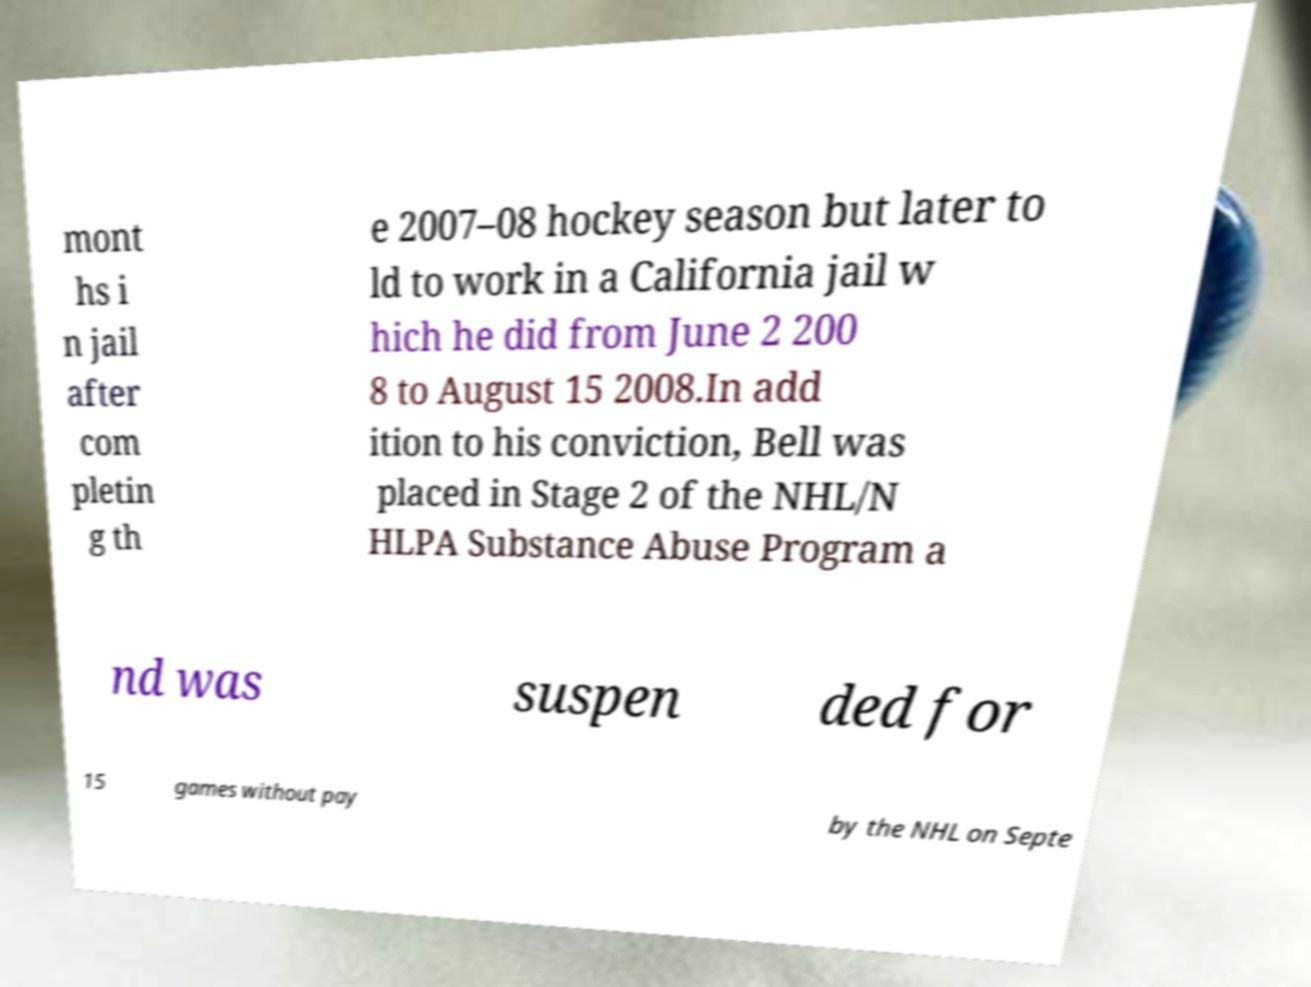Please identify and transcribe the text found in this image. mont hs i n jail after com pletin g th e 2007–08 hockey season but later to ld to work in a California jail w hich he did from June 2 200 8 to August 15 2008.In add ition to his conviction, Bell was placed in Stage 2 of the NHL/N HLPA Substance Abuse Program a nd was suspen ded for 15 games without pay by the NHL on Septe 